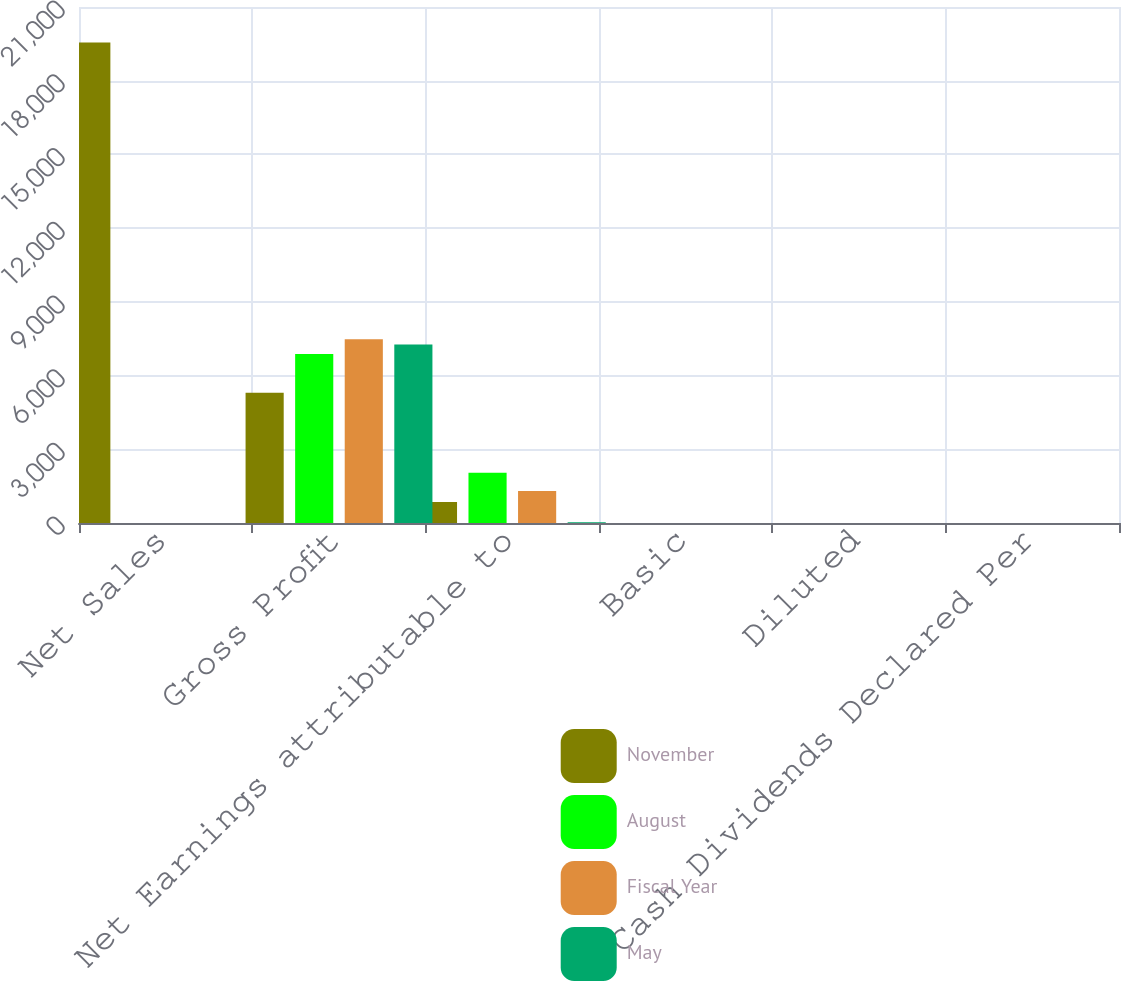Convert chart. <chart><loc_0><loc_0><loc_500><loc_500><stacked_bar_chart><ecel><fcel>Net Sales<fcel>Gross Profit<fcel>Net Earnings attributable to<fcel>Basic<fcel>Diluted<fcel>Cash Dividends Declared Per<nl><fcel>November<fcel>19554<fcel>5296<fcel>850<fcel>0.9<fcel>0.89<fcel>0.34<nl><fcel>August<fcel>1.93<fcel>6882<fcel>2042<fcel>1.96<fcel>1.93<fcel>0.34<nl><fcel>Fiscal Year<fcel>1.93<fcel>7481<fcel>1302<fcel>1.19<fcel>1.18<fcel>0.34<nl><fcel>May<fcel>1.93<fcel>7265<fcel>26<fcel>0.02<fcel>0.02<fcel>0.36<nl></chart> 